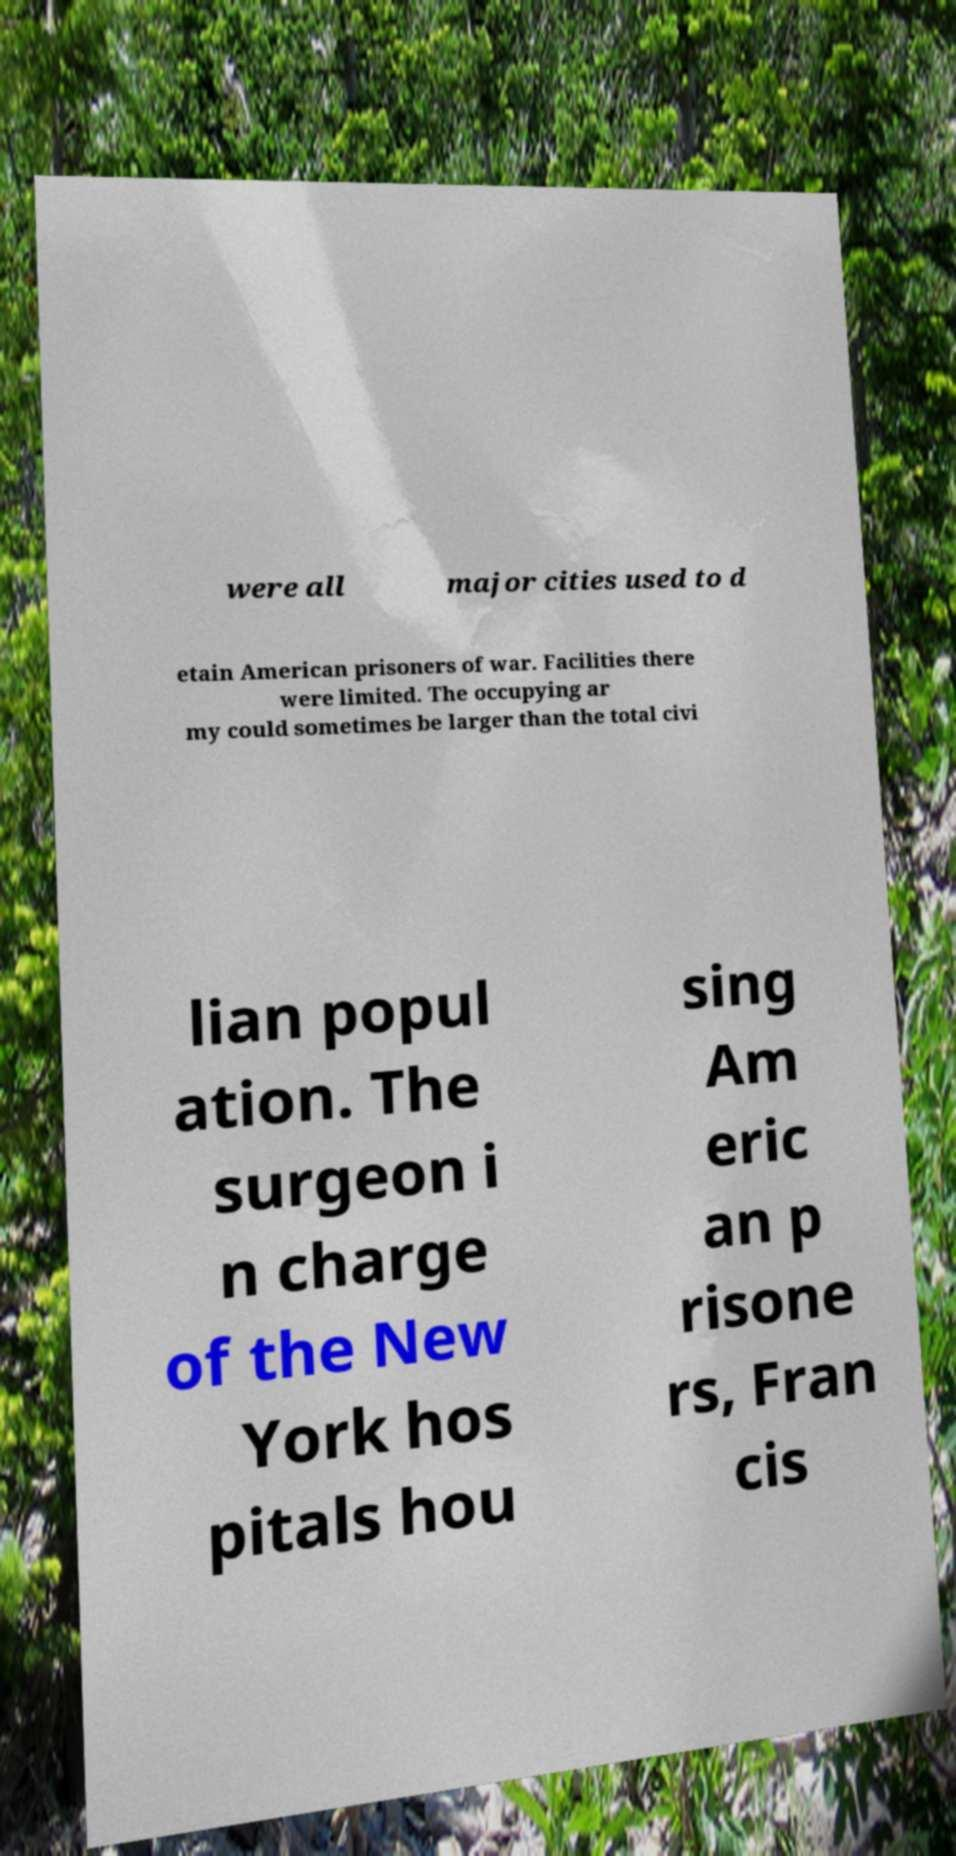I need the written content from this picture converted into text. Can you do that? were all major cities used to d etain American prisoners of war. Facilities there were limited. The occupying ar my could sometimes be larger than the total civi lian popul ation. The surgeon i n charge of the New York hos pitals hou sing Am eric an p risone rs, Fran cis 